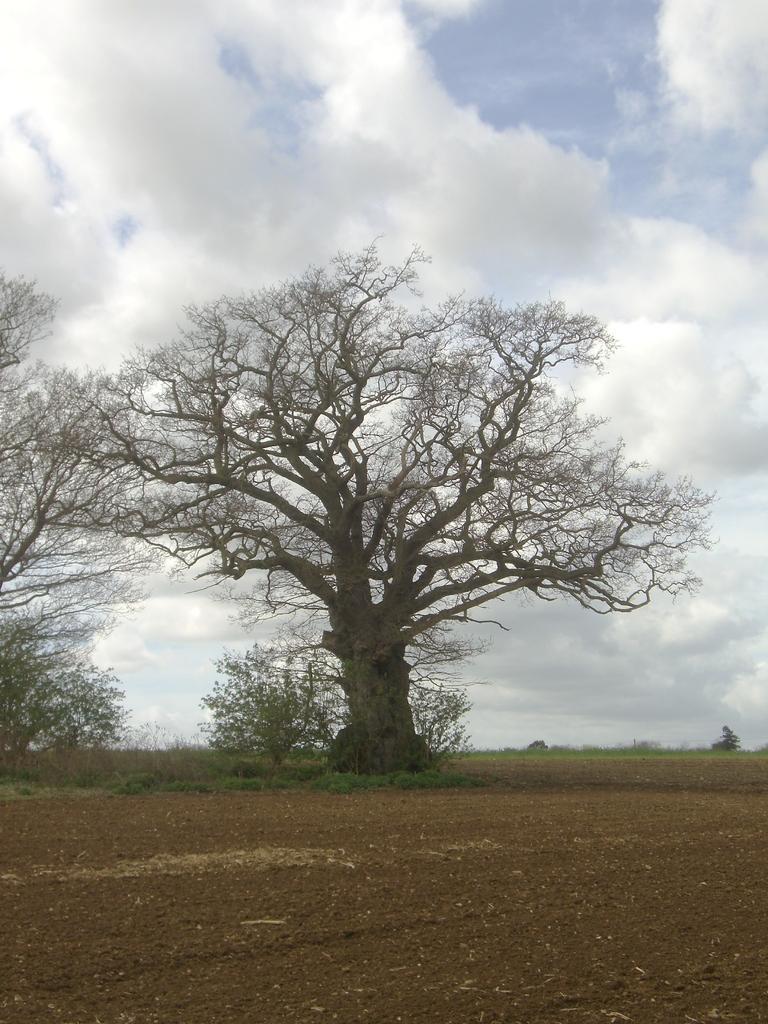In one or two sentences, can you explain what this image depicts? In this image at the bottom there is sand and grass and in the center there are some trees and plants, on the top of the image there is sky. 